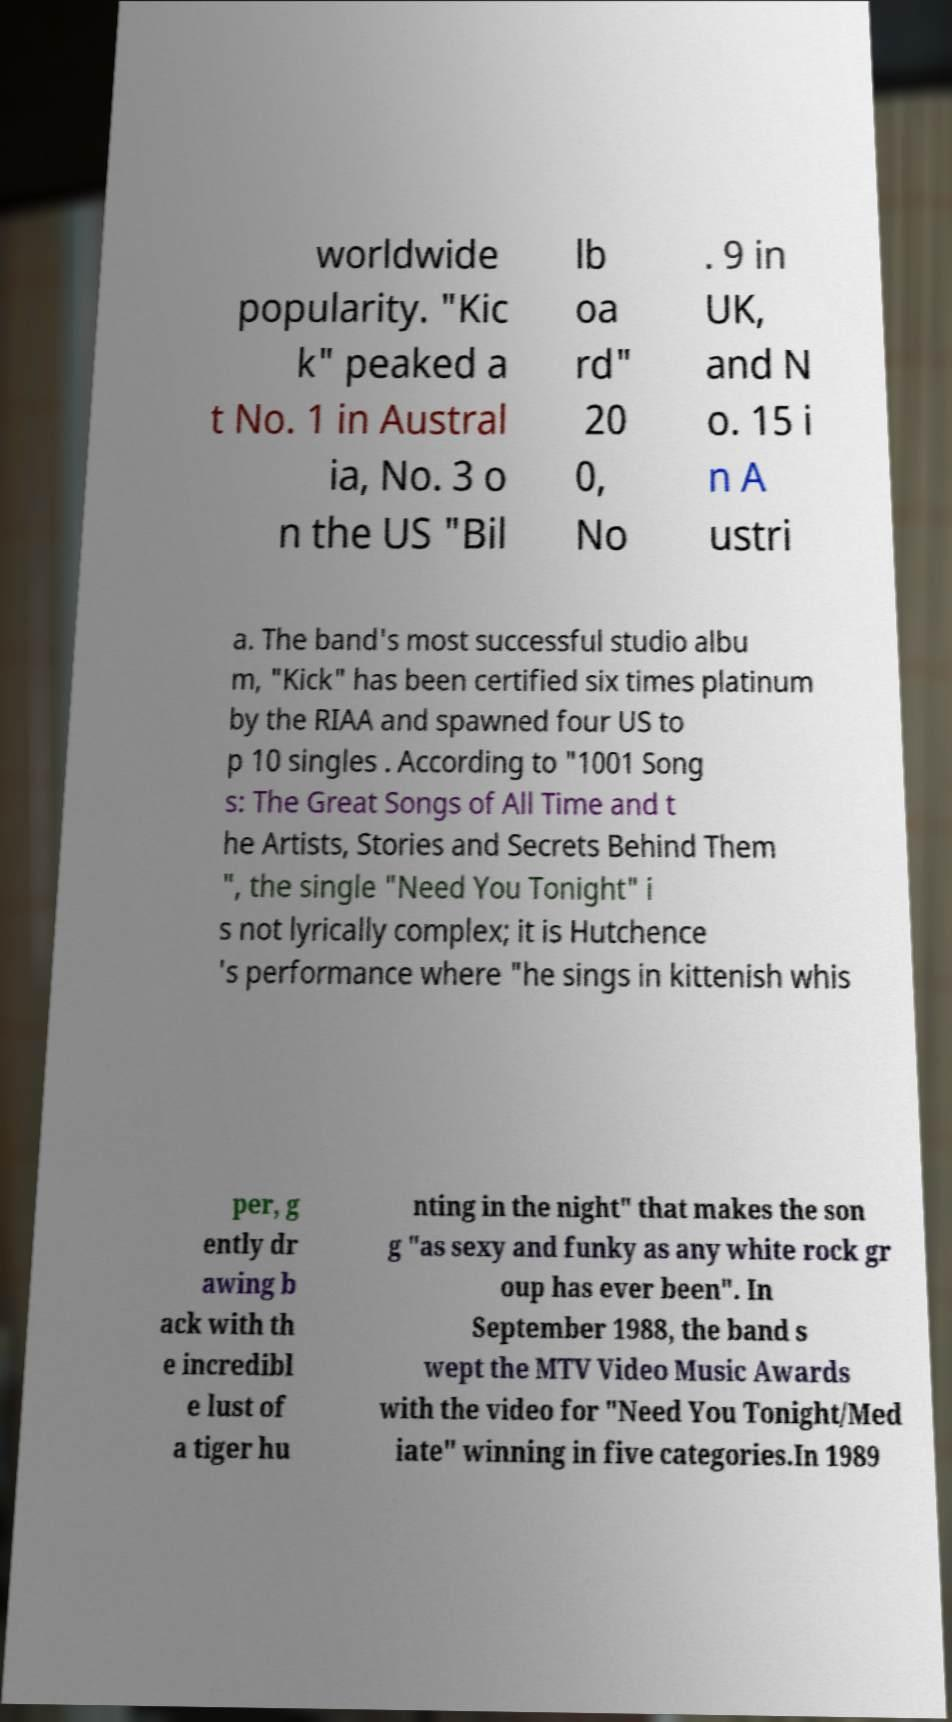What messages or text are displayed in this image? I need them in a readable, typed format. worldwide popularity. "Kic k" peaked a t No. 1 in Austral ia, No. 3 o n the US "Bil lb oa rd" 20 0, No . 9 in UK, and N o. 15 i n A ustri a. The band's most successful studio albu m, "Kick" has been certified six times platinum by the RIAA and spawned four US to p 10 singles . According to "1001 Song s: The Great Songs of All Time and t he Artists, Stories and Secrets Behind Them ", the single "Need You Tonight" i s not lyrically complex; it is Hutchence 's performance where "he sings in kittenish whis per, g ently dr awing b ack with th e incredibl e lust of a tiger hu nting in the night" that makes the son g "as sexy and funky as any white rock gr oup has ever been". In September 1988, the band s wept the MTV Video Music Awards with the video for "Need You Tonight/Med iate" winning in five categories.In 1989 